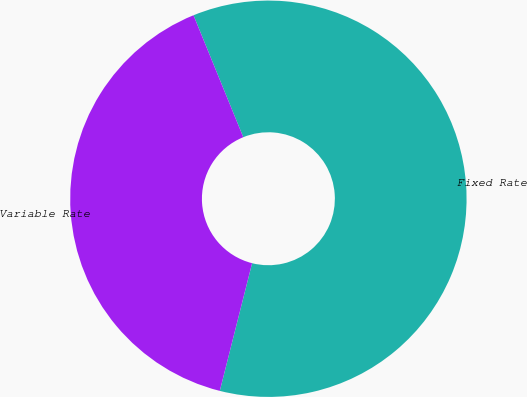Convert chart to OTSL. <chart><loc_0><loc_0><loc_500><loc_500><pie_chart><fcel>Fixed Rate<fcel>Variable Rate<nl><fcel>60.11%<fcel>39.89%<nl></chart> 